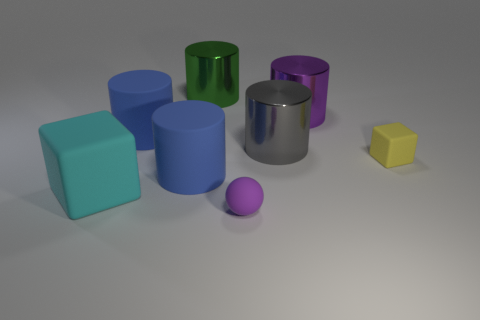There is a metallic cylinder that is the same color as the small matte sphere; what size is it?
Your answer should be compact. Large. Is there a yellow rubber cube?
Offer a very short reply. Yes. Does the purple thing that is in front of the large cyan cube have the same shape as the big blue object that is in front of the yellow matte thing?
Make the answer very short. No. Is there a blue cube that has the same material as the big green object?
Provide a succinct answer. No. Is the material of the small object that is in front of the yellow rubber block the same as the green cylinder?
Provide a short and direct response. No. Is the number of purple balls behind the green metallic object greater than the number of large cyan matte blocks on the right side of the purple cylinder?
Your answer should be compact. No. What is the color of the block that is the same size as the purple metallic thing?
Your response must be concise. Cyan. Are there any large metallic things of the same color as the ball?
Offer a terse response. Yes. Do the block left of the big green metallic object and the matte object behind the gray thing have the same color?
Provide a short and direct response. No. There is a block to the left of the small yellow object; what is it made of?
Give a very brief answer. Rubber. 